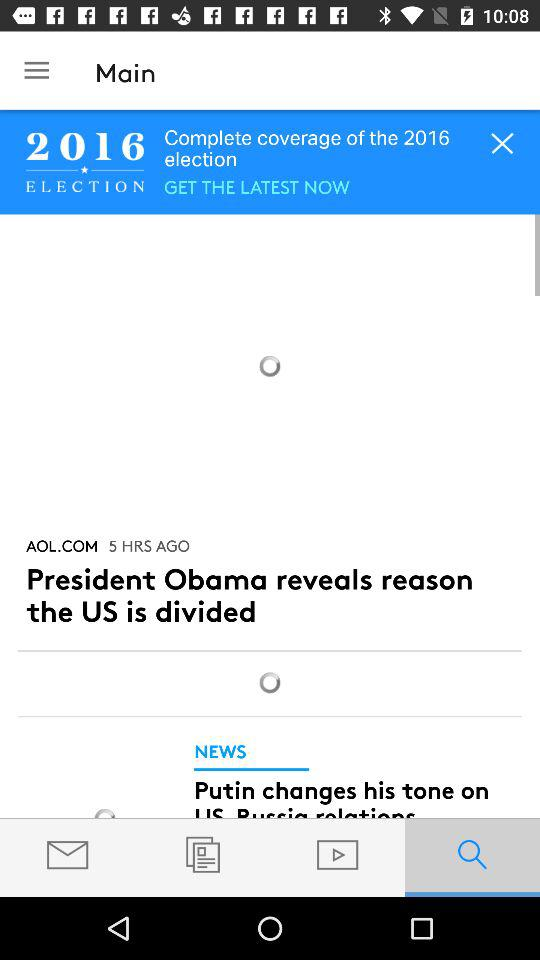How many news articles are there?
Answer the question using a single word or phrase. 2 